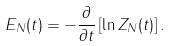Convert formula to latex. <formula><loc_0><loc_0><loc_500><loc_500>E _ { N } ( t ) = - \frac { \partial } { \partial t } \left [ \ln Z _ { N } ( t ) \right ] .</formula> 